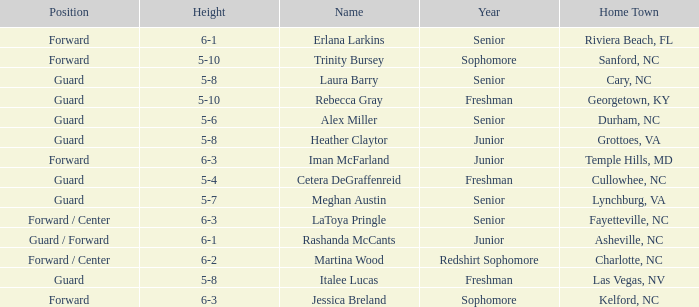What is the height of the player from Las Vegas, NV? 5-8. 